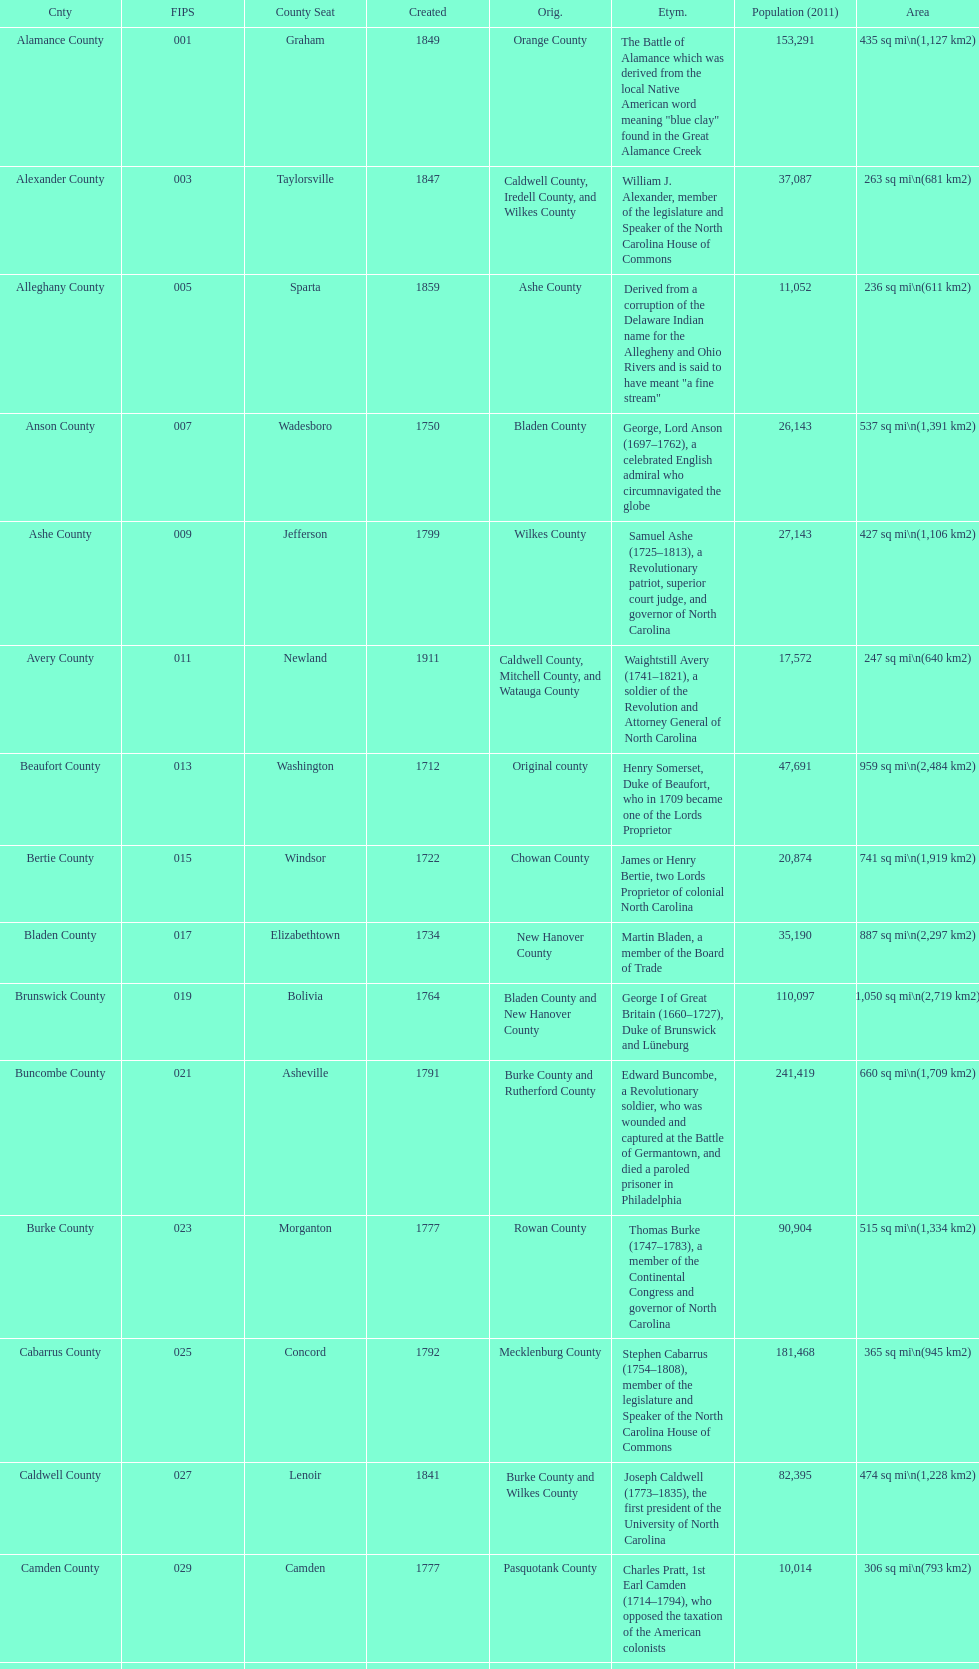Which is the only county with a name derived from a battle? Alamance County. 